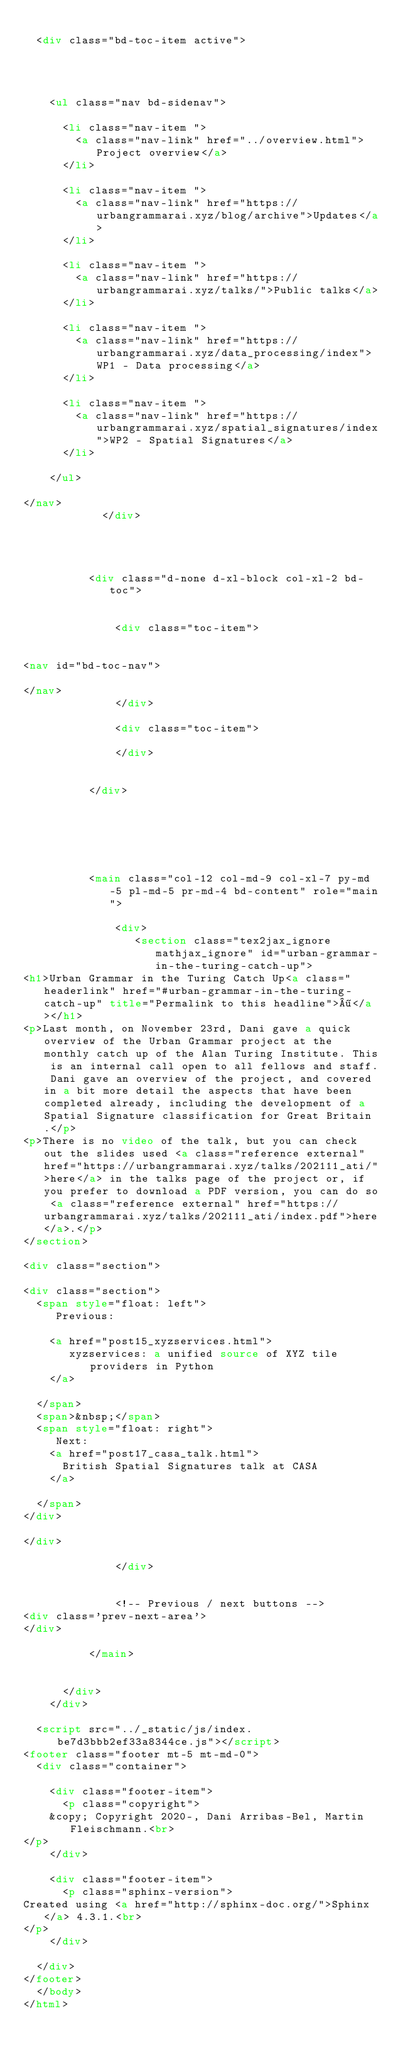<code> <loc_0><loc_0><loc_500><loc_500><_HTML_>
  <div class="bd-toc-item active">
    



    <ul class="nav bd-sidenav">
      
      <li class="nav-item ">
        <a class="nav-link" href="../overview.html">Project overview</a>
      </li>
      
      <li class="nav-item ">
        <a class="nav-link" href="https://urbangrammarai.xyz/blog/archive">Updates</a>
      </li>
      
      <li class="nav-item ">
        <a class="nav-link" href="https://urbangrammarai.xyz/talks/">Public talks</a>
      </li>
      
      <li class="nav-item ">
        <a class="nav-link" href="https://urbangrammarai.xyz/data_processing/index">WP1 - Data processing</a>
      </li>
      
      <li class="nav-item ">
        <a class="nav-link" href="https://urbangrammarai.xyz/spatial_signatures/index">WP2 - Spatial Signatures</a>
      </li>
      
    </ul>

</nav>
            </div>
            
          

          
          <div class="d-none d-xl-block col-xl-2 bd-toc">
            
              
              <div class="toc-item">
                

<nav id="bd-toc-nav">
    
</nav>
              </div>
              
              <div class="toc-item">
                
              </div>
              
            
          </div>
          

          
          
            
          
          <main class="col-12 col-md-9 col-xl-7 py-md-5 pl-md-5 pr-md-4 bd-content" role="main">
              
              <div>
                 <section class="tex2jax_ignore mathjax_ignore" id="urban-grammar-in-the-turing-catch-up">
<h1>Urban Grammar in the Turing Catch Up<a class="headerlink" href="#urban-grammar-in-the-turing-catch-up" title="Permalink to this headline">¶</a></h1>
<p>Last month, on November 23rd, Dani gave a quick overview of the Urban Grammar project at the monthly catch up of the Alan Turing Institute. This is an internal call open to all fellows and staff. Dani gave an overview of the project, and covered in a bit more detail the aspects that have been completed already, including the development of a Spatial Signature classification for Great Britain.</p>
<p>There is no video of the talk, but you can check out the slides used <a class="reference external" href="https://urbangrammarai.xyz/talks/202111_ati/">here</a> in the talks page of the project or, if you prefer to download a PDF version, you can do so <a class="reference external" href="https://urbangrammarai.xyz/talks/202111_ati/index.pdf">here</a>.</p>
</section>

<div class="section">
     
<div class="section">
  <span style="float: left">
     Previous:
    
    <a href="post15_xyzservices.html">
       xyzservices: a unified source of XYZ tile providers in Python
    </a>
    
  </span>
  <span>&nbsp;</span>
  <span style="float: right">
     Next: 
    <a href="post17_casa_talk.html">
      British Spatial Signatures talk at CASA 
    </a>
    
  </span>
</div>
  
</div>

              </div>
              
              
              <!-- Previous / next buttons -->
<div class='prev-next-area'>
</div>
              
          </main>
          

      </div>
    </div>
  
  <script src="../_static/js/index.be7d3bbb2ef33a8344ce.js"></script>
<footer class="footer mt-5 mt-md-0">
  <div class="container">
    
    <div class="footer-item">
      <p class="copyright">
    &copy; Copyright 2020-, Dani Arribas-Bel, Martin Fleischmann.<br>
</p>
    </div>
    
    <div class="footer-item">
      <p class="sphinx-version">
Created using <a href="http://sphinx-doc.org/">Sphinx</a> 4.3.1.<br>
</p>
    </div>
    
  </div>
</footer>
  </body>
</html></code> 